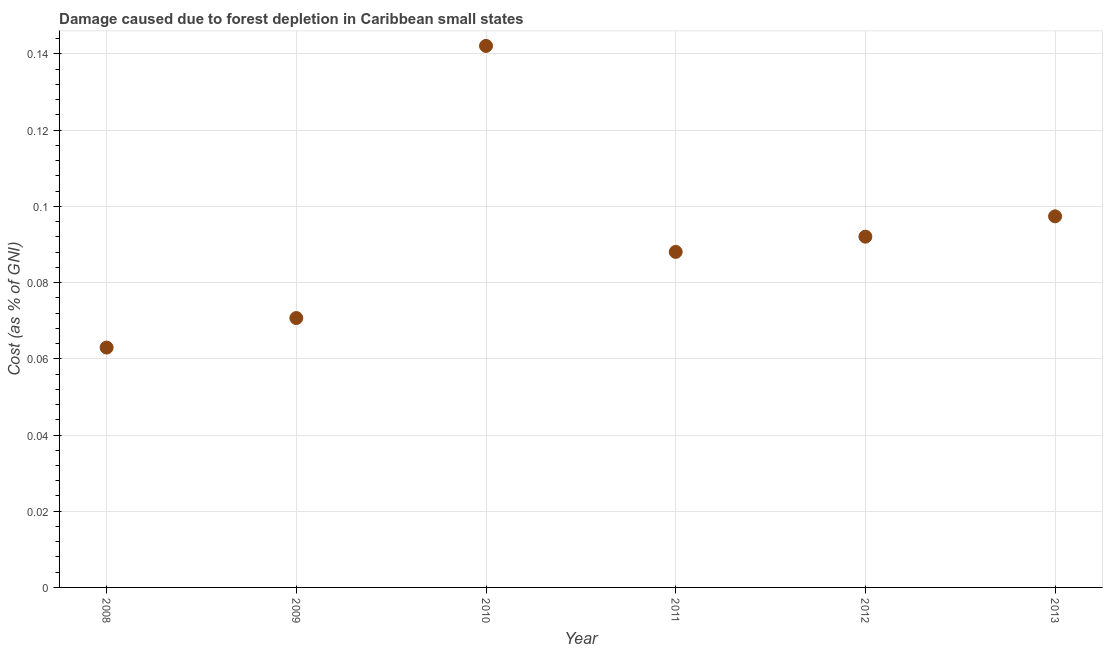What is the damage caused due to forest depletion in 2012?
Give a very brief answer. 0.09. Across all years, what is the maximum damage caused due to forest depletion?
Offer a very short reply. 0.14. Across all years, what is the minimum damage caused due to forest depletion?
Make the answer very short. 0.06. In which year was the damage caused due to forest depletion maximum?
Keep it short and to the point. 2010. In which year was the damage caused due to forest depletion minimum?
Offer a very short reply. 2008. What is the sum of the damage caused due to forest depletion?
Your answer should be very brief. 0.55. What is the difference between the damage caused due to forest depletion in 2011 and 2013?
Give a very brief answer. -0.01. What is the average damage caused due to forest depletion per year?
Provide a succinct answer. 0.09. What is the median damage caused due to forest depletion?
Your answer should be compact. 0.09. In how many years, is the damage caused due to forest depletion greater than 0.10400000000000001 %?
Give a very brief answer. 1. What is the ratio of the damage caused due to forest depletion in 2008 to that in 2012?
Provide a short and direct response. 0.68. Is the damage caused due to forest depletion in 2009 less than that in 2013?
Your answer should be very brief. Yes. Is the difference between the damage caused due to forest depletion in 2008 and 2011 greater than the difference between any two years?
Offer a terse response. No. What is the difference between the highest and the second highest damage caused due to forest depletion?
Your answer should be compact. 0.04. What is the difference between the highest and the lowest damage caused due to forest depletion?
Provide a short and direct response. 0.08. How many dotlines are there?
Keep it short and to the point. 1. What is the difference between two consecutive major ticks on the Y-axis?
Ensure brevity in your answer.  0.02. Are the values on the major ticks of Y-axis written in scientific E-notation?
Keep it short and to the point. No. Does the graph contain any zero values?
Keep it short and to the point. No. What is the title of the graph?
Offer a terse response. Damage caused due to forest depletion in Caribbean small states. What is the label or title of the Y-axis?
Ensure brevity in your answer.  Cost (as % of GNI). What is the Cost (as % of GNI) in 2008?
Give a very brief answer. 0.06. What is the Cost (as % of GNI) in 2009?
Your response must be concise. 0.07. What is the Cost (as % of GNI) in 2010?
Keep it short and to the point. 0.14. What is the Cost (as % of GNI) in 2011?
Provide a short and direct response. 0.09. What is the Cost (as % of GNI) in 2012?
Provide a short and direct response. 0.09. What is the Cost (as % of GNI) in 2013?
Provide a succinct answer. 0.1. What is the difference between the Cost (as % of GNI) in 2008 and 2009?
Provide a succinct answer. -0.01. What is the difference between the Cost (as % of GNI) in 2008 and 2010?
Provide a short and direct response. -0.08. What is the difference between the Cost (as % of GNI) in 2008 and 2011?
Provide a succinct answer. -0.03. What is the difference between the Cost (as % of GNI) in 2008 and 2012?
Your answer should be very brief. -0.03. What is the difference between the Cost (as % of GNI) in 2008 and 2013?
Offer a terse response. -0.03. What is the difference between the Cost (as % of GNI) in 2009 and 2010?
Keep it short and to the point. -0.07. What is the difference between the Cost (as % of GNI) in 2009 and 2011?
Your response must be concise. -0.02. What is the difference between the Cost (as % of GNI) in 2009 and 2012?
Ensure brevity in your answer.  -0.02. What is the difference between the Cost (as % of GNI) in 2009 and 2013?
Keep it short and to the point. -0.03. What is the difference between the Cost (as % of GNI) in 2010 and 2011?
Your answer should be very brief. 0.05. What is the difference between the Cost (as % of GNI) in 2010 and 2012?
Your answer should be very brief. 0.05. What is the difference between the Cost (as % of GNI) in 2010 and 2013?
Your answer should be compact. 0.04. What is the difference between the Cost (as % of GNI) in 2011 and 2012?
Your answer should be very brief. -0. What is the difference between the Cost (as % of GNI) in 2011 and 2013?
Keep it short and to the point. -0.01. What is the difference between the Cost (as % of GNI) in 2012 and 2013?
Your response must be concise. -0.01. What is the ratio of the Cost (as % of GNI) in 2008 to that in 2009?
Provide a succinct answer. 0.89. What is the ratio of the Cost (as % of GNI) in 2008 to that in 2010?
Your answer should be very brief. 0.44. What is the ratio of the Cost (as % of GNI) in 2008 to that in 2011?
Provide a short and direct response. 0.71. What is the ratio of the Cost (as % of GNI) in 2008 to that in 2012?
Keep it short and to the point. 0.68. What is the ratio of the Cost (as % of GNI) in 2008 to that in 2013?
Keep it short and to the point. 0.65. What is the ratio of the Cost (as % of GNI) in 2009 to that in 2010?
Offer a terse response. 0.5. What is the ratio of the Cost (as % of GNI) in 2009 to that in 2011?
Give a very brief answer. 0.8. What is the ratio of the Cost (as % of GNI) in 2009 to that in 2012?
Your answer should be compact. 0.77. What is the ratio of the Cost (as % of GNI) in 2009 to that in 2013?
Ensure brevity in your answer.  0.73. What is the ratio of the Cost (as % of GNI) in 2010 to that in 2011?
Keep it short and to the point. 1.61. What is the ratio of the Cost (as % of GNI) in 2010 to that in 2012?
Your answer should be compact. 1.54. What is the ratio of the Cost (as % of GNI) in 2010 to that in 2013?
Offer a terse response. 1.46. What is the ratio of the Cost (as % of GNI) in 2011 to that in 2012?
Provide a short and direct response. 0.96. What is the ratio of the Cost (as % of GNI) in 2011 to that in 2013?
Offer a terse response. 0.9. What is the ratio of the Cost (as % of GNI) in 2012 to that in 2013?
Provide a short and direct response. 0.94. 